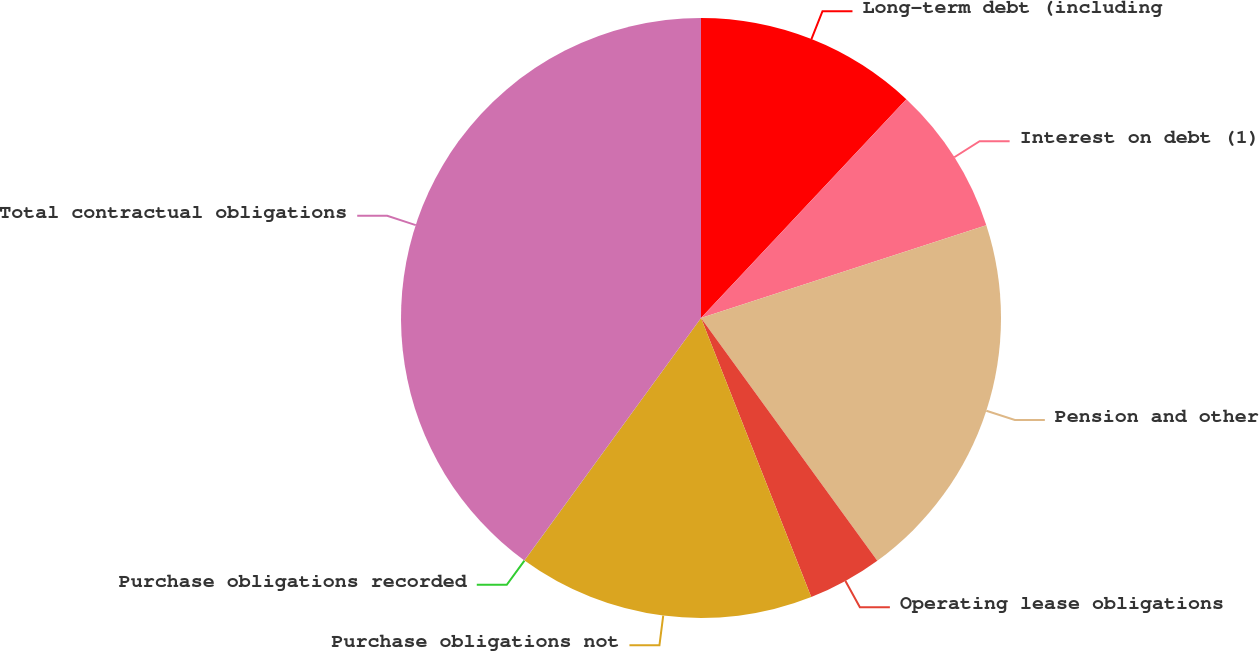<chart> <loc_0><loc_0><loc_500><loc_500><pie_chart><fcel>Long-term debt (including<fcel>Interest on debt (1)<fcel>Pension and other<fcel>Operating lease obligations<fcel>Purchase obligations not<fcel>Purchase obligations recorded<fcel>Total contractual obligations<nl><fcel>12.0%<fcel>8.0%<fcel>20.0%<fcel>4.01%<fcel>16.0%<fcel>0.01%<fcel>39.98%<nl></chart> 